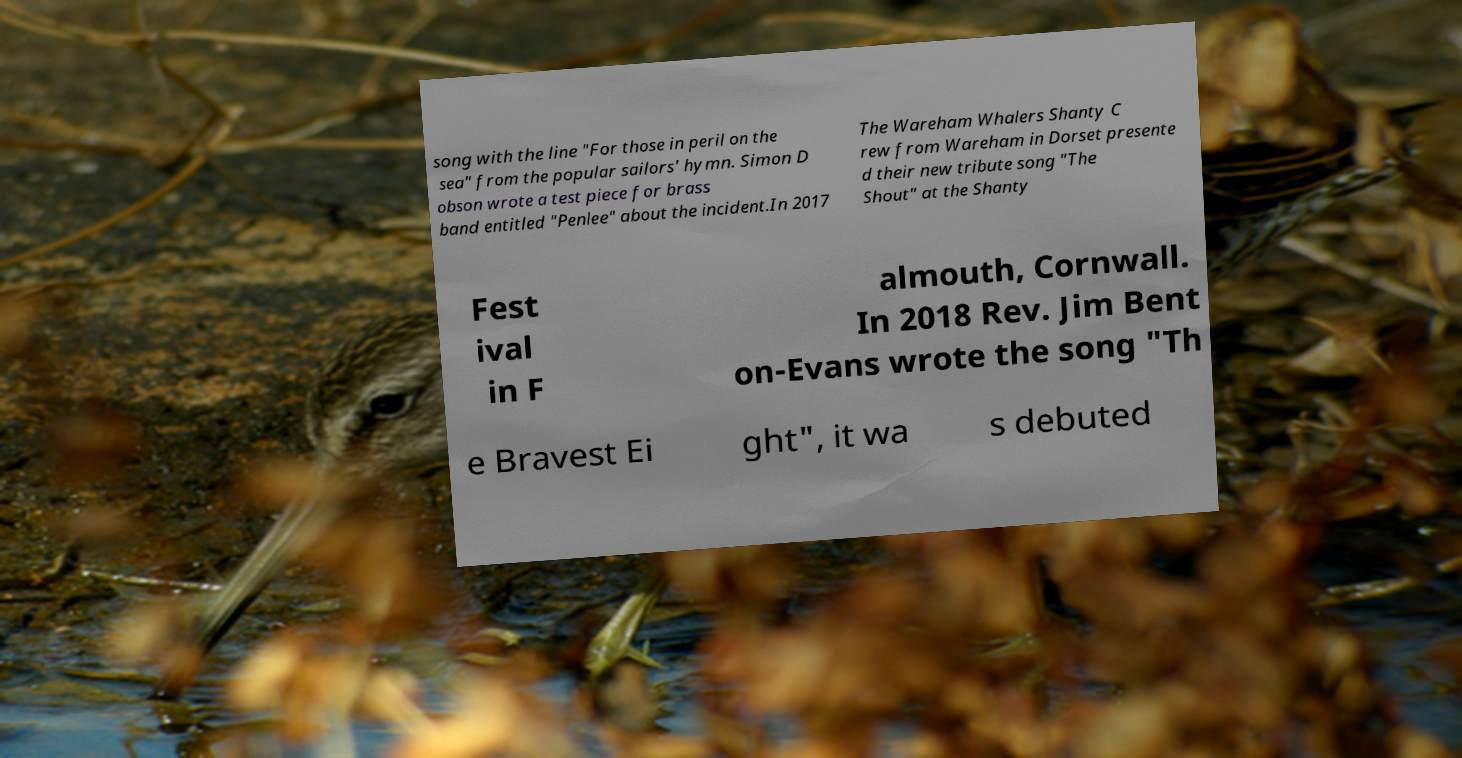Can you read and provide the text displayed in the image?This photo seems to have some interesting text. Can you extract and type it out for me? song with the line "For those in peril on the sea" from the popular sailors' hymn. Simon D obson wrote a test piece for brass band entitled "Penlee" about the incident.In 2017 The Wareham Whalers Shanty C rew from Wareham in Dorset presente d their new tribute song "The Shout" at the Shanty Fest ival in F almouth, Cornwall. In 2018 Rev. Jim Bent on-Evans wrote the song "Th e Bravest Ei ght", it wa s debuted 